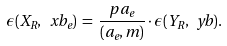<formula> <loc_0><loc_0><loc_500><loc_500>\epsilon ( X _ { R } , \ x b _ { e } ) \, = \, \frac { p \, a _ { e } } { ( a _ { e } , m ) } \cdot \epsilon ( Y _ { R } , \ y b ) .</formula> 